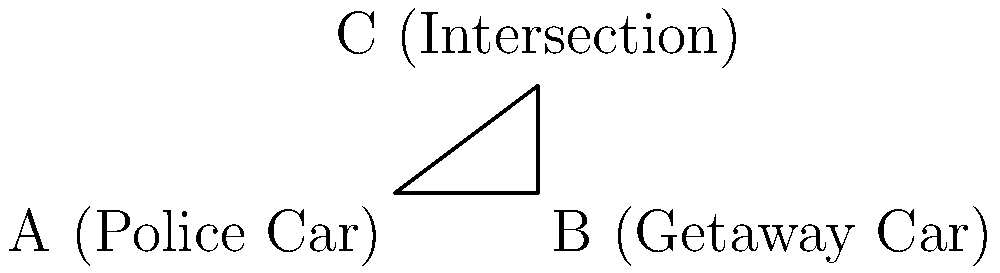In a high-speed chase scene from the movie "Legal Pursuit," a police car (A) is pursuing a getaway car (B) along a straight highway. The getaway car suddenly turns right at an intersection (C), creating a right-angled triangle. If the distance AB is 8 km, BC is 6 km, and the getaway car maintains a constant velocity v, at what angle θ (in degrees) should the police car drive to intercept the getaway car at the intersection, assuming both cars travel at the same speed? To solve this problem, we'll use vector analysis and the principle of relative motion:

1) First, we need to find the time it takes for the getaway car to reach point C:
   Time = Distance / Velocity
   $t = 6 / v$

2) In this time, the police car needs to travel the hypotenuse AC:
   $AC = \sqrt{AB^2 + BC^2} = \sqrt{8^2 + 6^2} = \sqrt{100} = 10$ km

3) For the police car to intercept at C, it must also take time $t$ to reach C:
   $10 / v = 6 / v$
   This confirms that both cars will reach C at the same time if they travel at the same speed.

4) Now, we can use trigonometry to find the angle θ:
   $\tan(\theta) = \frac{opposite}{adjacent} = \frac{BC}{AB} = \frac{6}{8} = 0.75$

5) To get θ, we take the inverse tangent (arctangent):
   $\theta = \arctan(0.75)$

6) Convert to degrees:
   $\theta \approx 36.87°$

Therefore, the police car should drive at an angle of approximately 36.87° to intercept the getaway car at the intersection.
Answer: 36.87° 